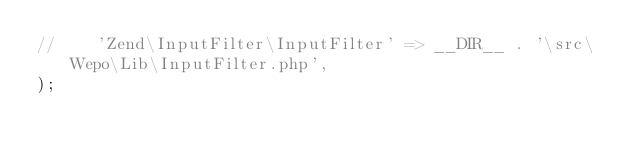Convert code to text. <code><loc_0><loc_0><loc_500><loc_500><_PHP_>//    'Zend\InputFilter\InputFilter' => __DIR__ . '\src\Wepo\Lib\InputFilter.php',
);
</code> 